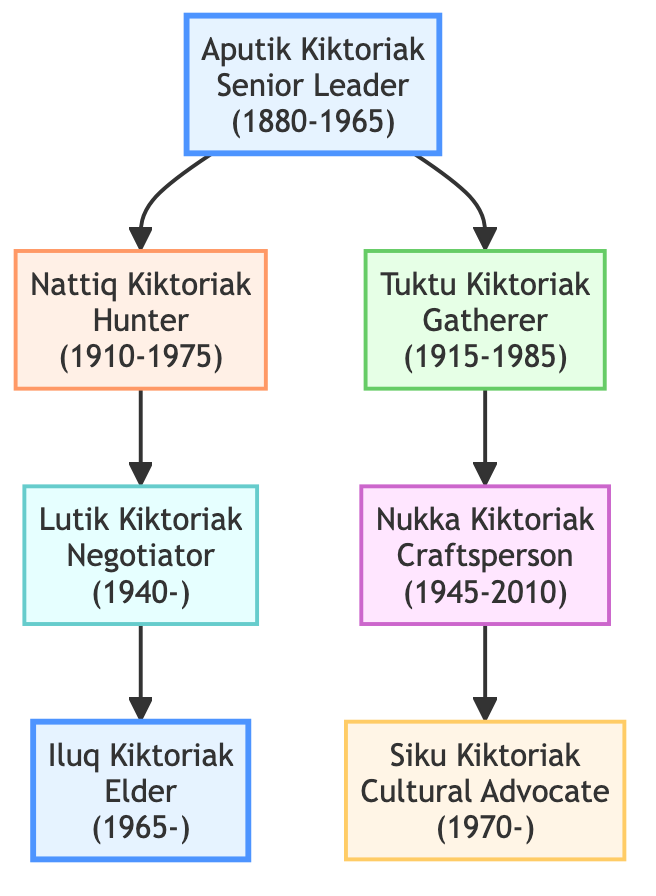What is Aputik Kiktoriak's role? The diagram shows that Aputik Kiktoriak is a "Senior Leader," which is indicated next to their name in the visual representation.
Answer: Senior Leader How many children did Aputik Kiktoriak have? By counting the edges that lead from Aputik Kiktoriak, we find two direct descendants: Nattiq Kiktoriak and Tuktu Kiktoriak.
Answer: 2 Who is the descendant of Nattiq Kiktoriak? Looking at the descendants of Nattiq Kiktoriak, I can see that Lutik Kiktoriak is the only listed descendant.
Answer: Lutik Kiktoriak What role does Siku Kiktoriak hold? The diagram specifies that Siku Kiktoriak's role is "Cultural Advocate," which is clearly stated next to their name in the family tree.
Answer: Cultural Advocate Which ancestor has the role of "Elder"? When examining the diagram, both Aputik Kiktoriak and Iluq Kiktoriak are identified as "Elder," with their roles indicated alongside their names.
Answer: Aputik Kiktoriak, Iluq Kiktoriak Who is the youngest descendant in the lineage? Tracing the lineage, the youngest individual is Siku Kiktoriak, born in 1970, as stated in the diagram.
Answer: Siku Kiktoriak What is the birth year of Nukka Kiktoriak? The diagram provides Nukka Kiktoriak's birth year as 1945, which is noted next to their name.
Answer: 1945 What role did Nattiq Kiktoriak fulfill? The diagram indicates that Nattiq Kiktoriak's role is "Hunter," which is mentioned beside their name.
Answer: Hunter How is Lutik Kiktoriak related to Aputik Kiktoriak? Lutik Kiktoriak is the grandson of Aputik Kiktoriak, as he is a descendant through Nattiq Kiktoriak.
Answer: Grandson 